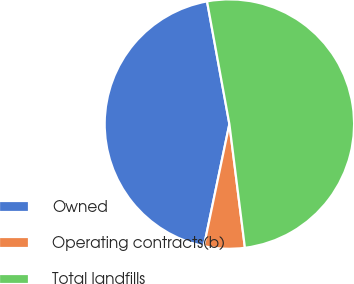<chart> <loc_0><loc_0><loc_500><loc_500><pie_chart><fcel>Owned<fcel>Operating contracts(b)<fcel>Total landfills<nl><fcel>43.86%<fcel>5.26%<fcel>50.88%<nl></chart> 